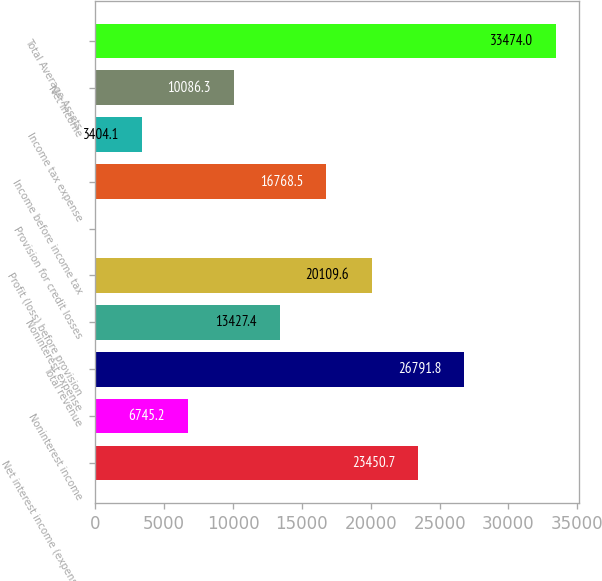Convert chart to OTSL. <chart><loc_0><loc_0><loc_500><loc_500><bar_chart><fcel>Net interest income (expense)<fcel>Noninterest income<fcel>Total revenue<fcel>Noninterest expense<fcel>Profit (loss) before provision<fcel>Provision for credit losses<fcel>Income before income tax<fcel>Income tax expense<fcel>Net income<fcel>Total Average Assets<nl><fcel>23450.7<fcel>6745.2<fcel>26791.8<fcel>13427.4<fcel>20109.6<fcel>63<fcel>16768.5<fcel>3404.1<fcel>10086.3<fcel>33474<nl></chart> 